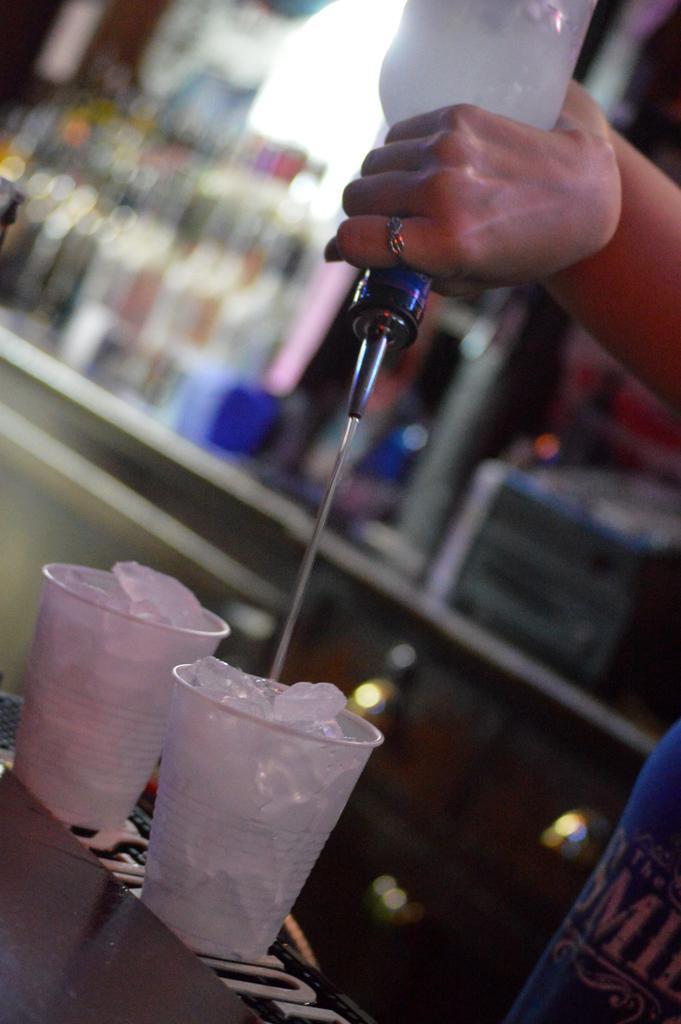Please provide a concise description of this image. In this image we can see ice cubes in two glasses, there is a bottle in the person's hand, there are bottles on the rack, and the background is blurred. 